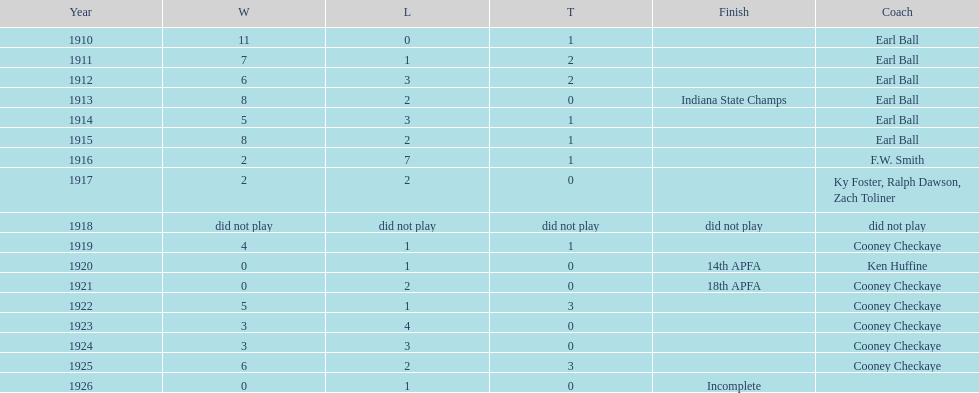How many years did cooney checkaye coach the muncie flyers? 6. 